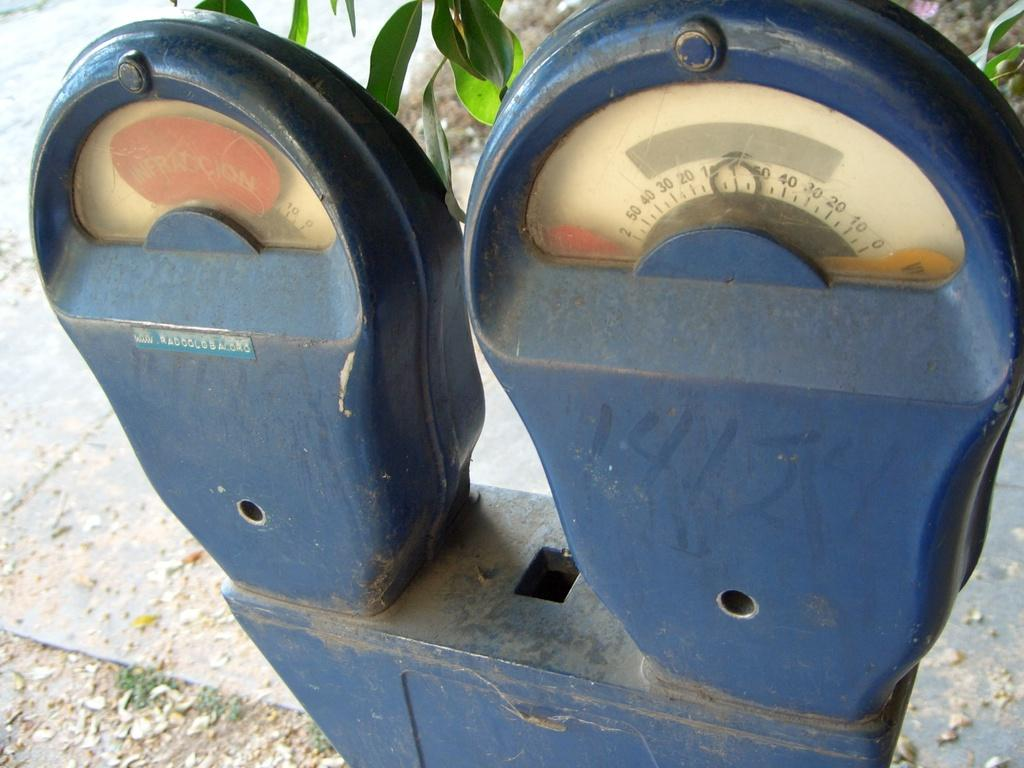<image>
Relay a brief, clear account of the picture shown. A rusty looking blue gauge on which the number 50 can be seen. 